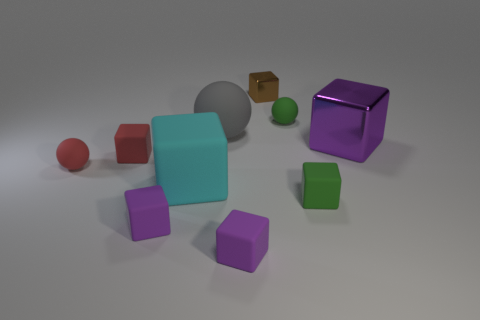What number of small rubber cubes are both to the right of the gray ball and left of the gray rubber object?
Your answer should be compact. 0. What number of things are gray things or matte things that are on the left side of the large gray sphere?
Provide a short and direct response. 5. The green sphere that is made of the same material as the red ball is what size?
Your response must be concise. Small. What shape is the green matte thing that is behind the small matte ball that is in front of the large sphere?
Offer a terse response. Sphere. How many purple objects are matte spheres or tiny metallic things?
Make the answer very short. 0. Is there a large purple thing that is left of the big thing behind the large block that is on the right side of the small brown block?
Offer a terse response. No. How many small objects are green cubes or blue matte things?
Ensure brevity in your answer.  1. Do the red matte object in front of the red matte block and the large gray object have the same shape?
Keep it short and to the point. Yes. Is the number of brown rubber cylinders less than the number of tiny purple rubber cubes?
Give a very brief answer. Yes. Is there anything else that has the same color as the large matte block?
Offer a very short reply. No. 